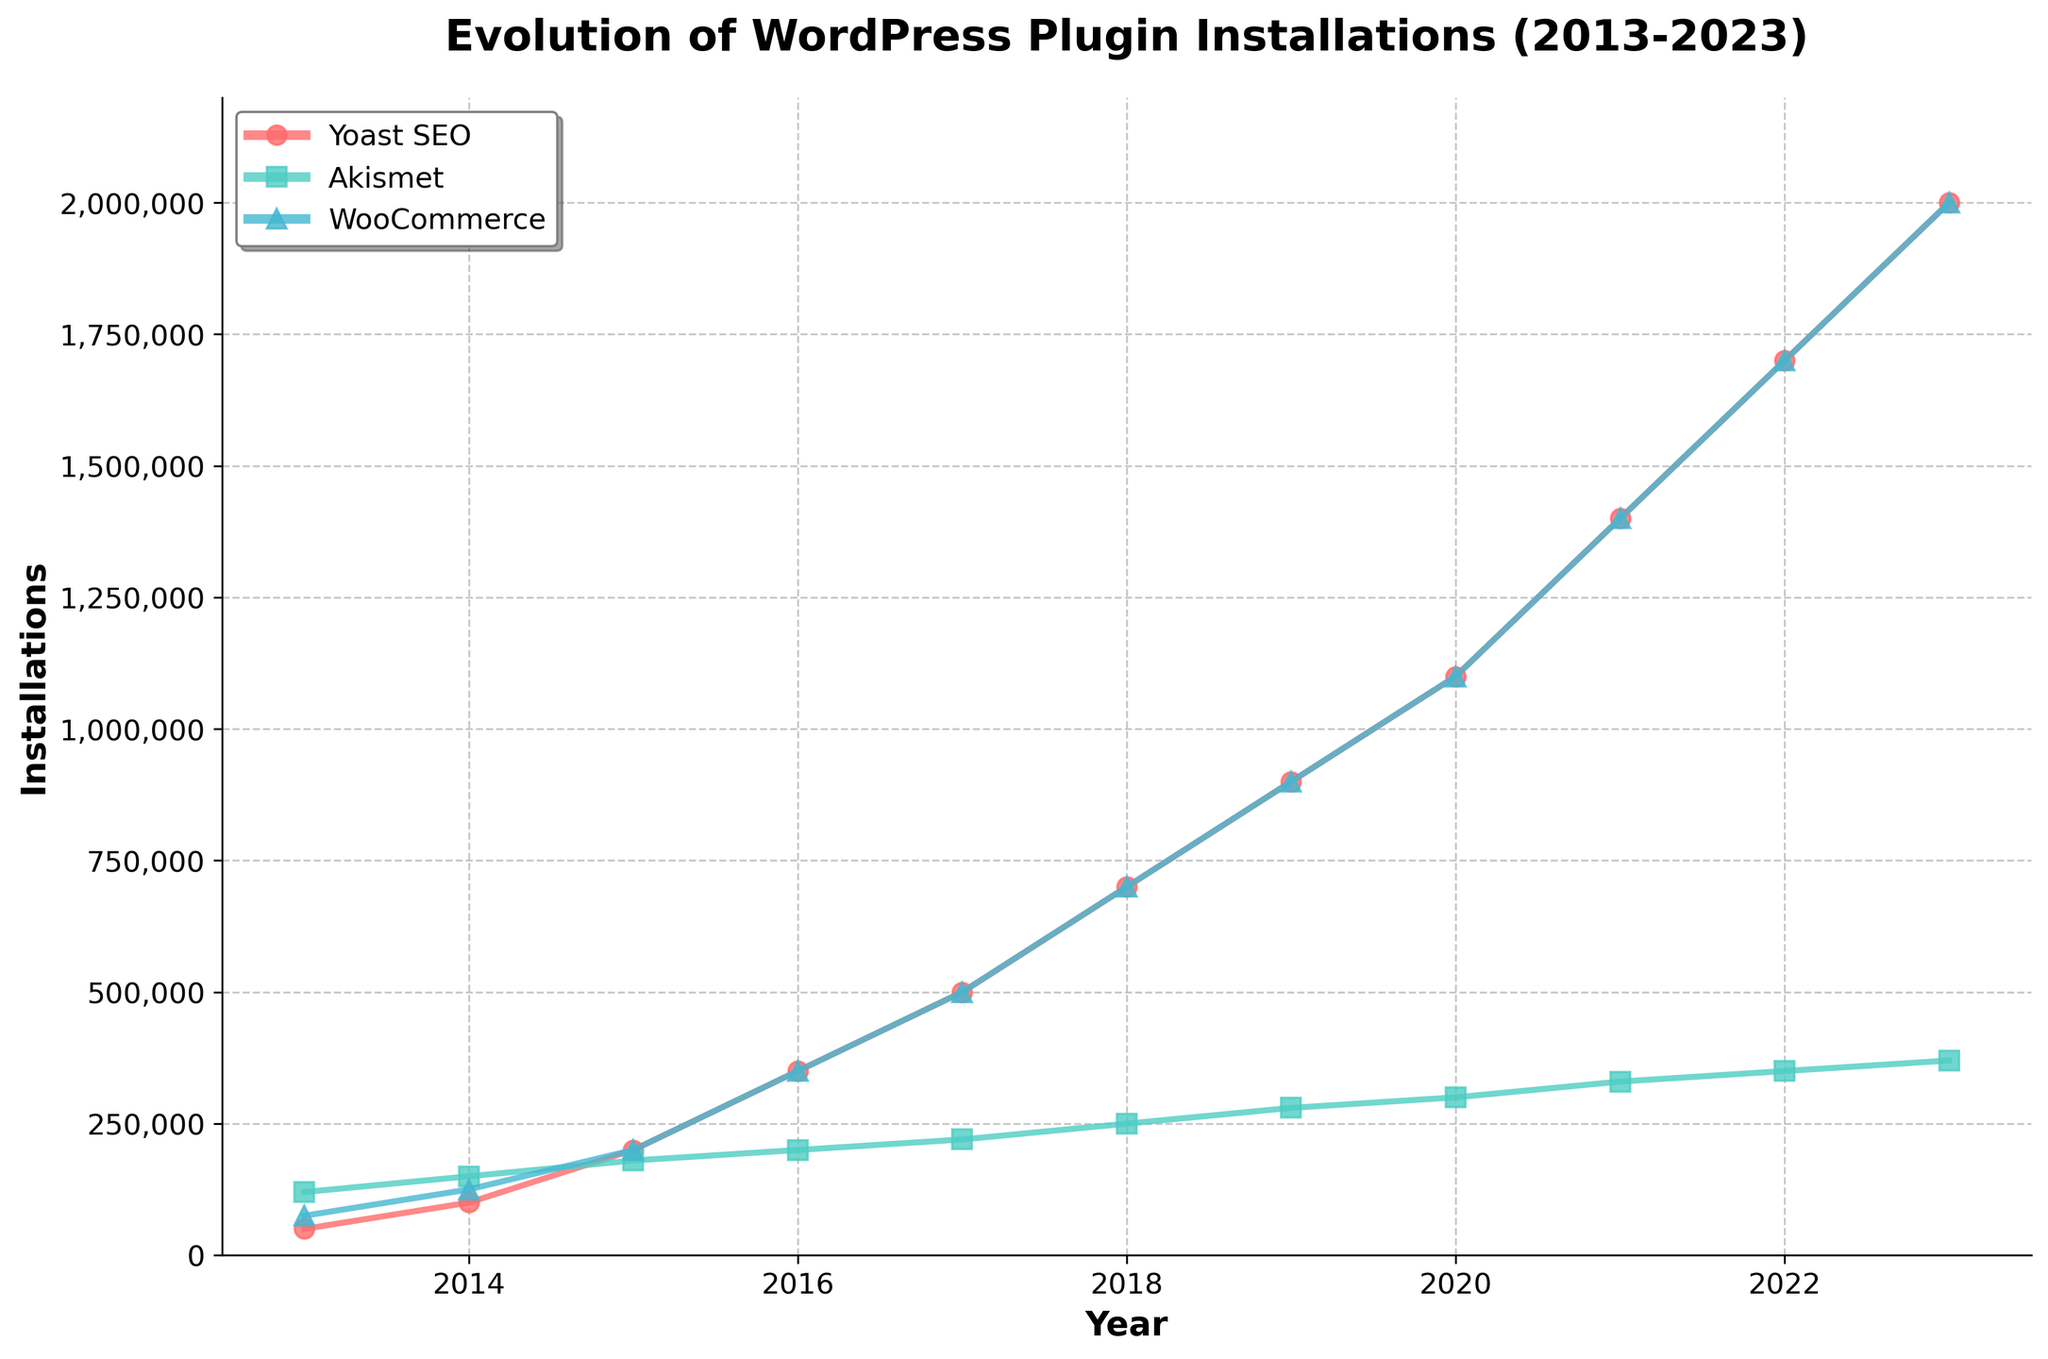What's the title of the plot? The title is displayed prominently at the top of the plot. The text of the title provides a direct indication of the content of the figure.
Answer: Evolution of WordPress Plugin Installations (2013-2023) What are the labels of the x-axis and y-axis? The labels are positioned along the axes of the plot. The x-axis label is at the bottom horizontal line, and the y-axis label is along the left vertical line.
Answer: x-axis: Year, y-axis: Installations Which plugin had the most installations in 2023? To find this, look at the data points for each plugin in the year 2023. Identify which plugin's data point reaches the highest value on the y-axis in 2023.
Answer: Yoast SEO and WooCommerce How did the installations of Akismet change from 2013 to 2023? Start with the installations in 2013 and follow the points in the plot until 2023, noting the change in position along the y-axis.
Answer: Increased by 250,000 (from 120,000 to 370,000) By how much did WooCommerce installations grow between 2014 and 2020? Find the installations for WooCommerce in 2014 and in 2020. Subtract the 2014 value from the 2020 value to determine the growth.
Answer: 975,000 (from 125,000 to 1,100,000) In what year did Yoast SEO surpass 1,000,000 installations? Trace the line for Yoast SEO and locate the year on the x-axis where the y-axis value first exceeds 1,000,000.
Answer: 2020 Which plugin had the least amount of installations in 2018? Compare the y-values of the data points for all three plugins in 2018. The one with the smallest y-value has the least installations.
Answer: Akismet How many plugins exceeded 300,000 installations in 2017? Identify the y-values for each plugin in 2017 and count how many are above 300,000.
Answer: One (Yoast SEO and WooCommerce) What's the average number of installations for Akismet from 2013 to 2023? Add the installation values for Akismet for all years from 2013 to 2023, then divide by the number of years.
Answer: 242,727.27 Between which two consecutive years did WooCommerce experience its largest increase in installations? Calculate the year-over-year increase for WooCommerce installations by subtracting the previous year's value from the current year's value. Identify the largest difference.
Answer: 2017 to 2018 